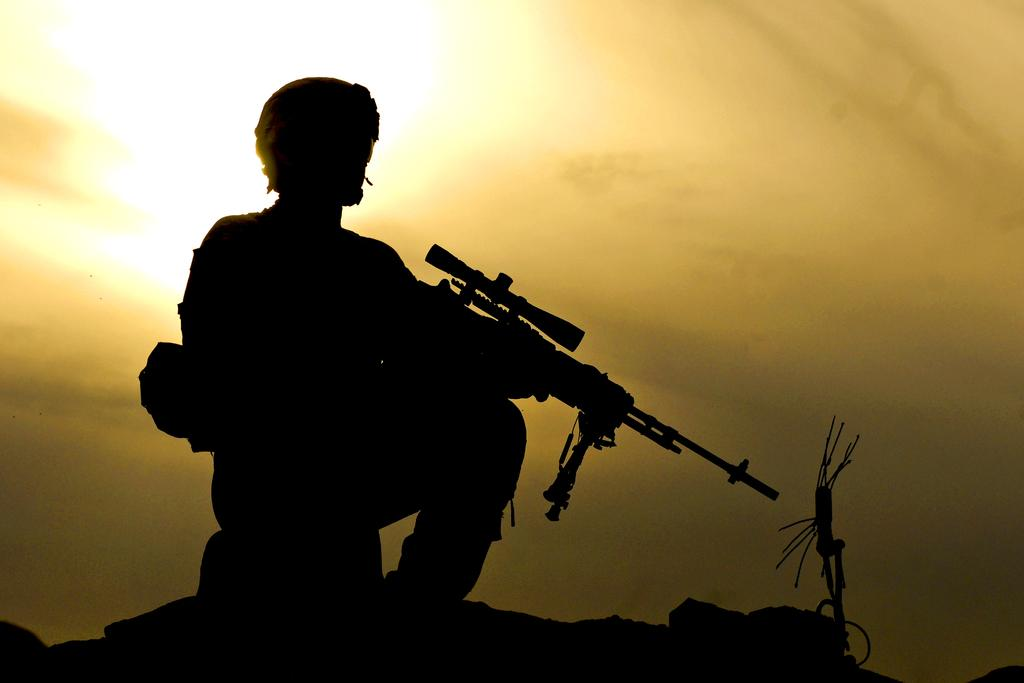What is the main subject of the image? The main subject of the image is a man. What is the man holding in the image? The man is holding a gun in the image. Where is the man sitting in the image? The man is sitting on a rock in the image. What can be seen in the background of the image? There is a sky visible in the background of the image. What type of ornament is hanging from the man's neck in the image? There is no ornament hanging from the man's neck in the image. 